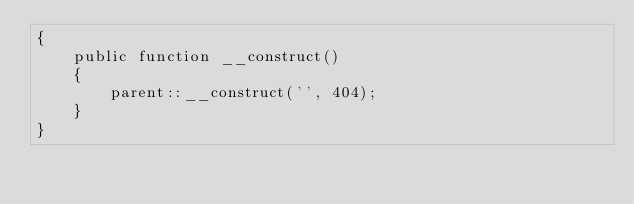Convert code to text. <code><loc_0><loc_0><loc_500><loc_500><_PHP_>{
    public function __construct()
    {
        parent::__construct('', 404);
    }
}</code> 